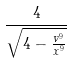<formula> <loc_0><loc_0><loc_500><loc_500>\frac { 4 } { \sqrt { 4 - \frac { v ^ { 9 } } { x ^ { 9 } } } }</formula> 